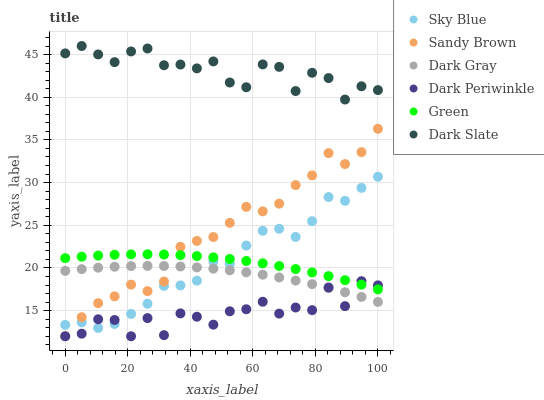Does Dark Periwinkle have the minimum area under the curve?
Answer yes or no. Yes. Does Dark Slate have the maximum area under the curve?
Answer yes or no. Yes. Does Green have the minimum area under the curve?
Answer yes or no. No. Does Green have the maximum area under the curve?
Answer yes or no. No. Is Green the smoothest?
Answer yes or no. Yes. Is Dark Periwinkle the roughest?
Answer yes or no. Yes. Is Dark Slate the smoothest?
Answer yes or no. No. Is Dark Slate the roughest?
Answer yes or no. No. Does Sandy Brown have the lowest value?
Answer yes or no. Yes. Does Green have the lowest value?
Answer yes or no. No. Does Dark Slate have the highest value?
Answer yes or no. Yes. Does Green have the highest value?
Answer yes or no. No. Is Green less than Dark Slate?
Answer yes or no. Yes. Is Dark Slate greater than Green?
Answer yes or no. Yes. Does Green intersect Sky Blue?
Answer yes or no. Yes. Is Green less than Sky Blue?
Answer yes or no. No. Is Green greater than Sky Blue?
Answer yes or no. No. Does Green intersect Dark Slate?
Answer yes or no. No. 